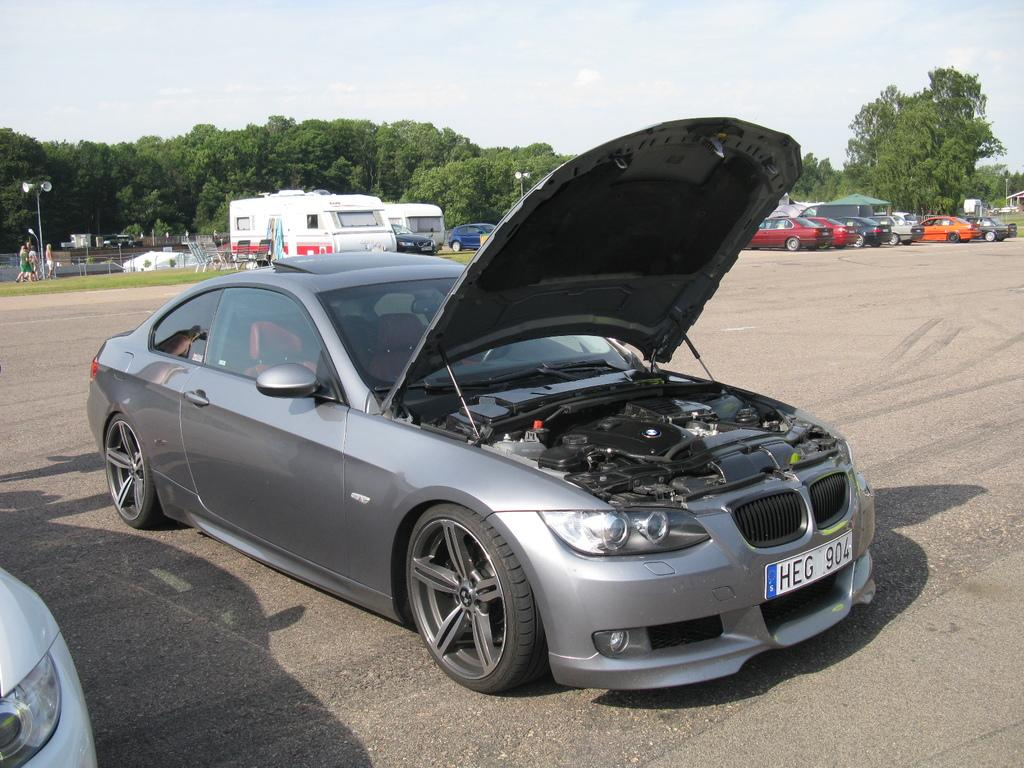What can be seen on the road in the image? There are many vehicles on the road in the image. What is located to the left of the image? There are poles to the left of the image. What is near the poles? There are people near the poles. What is visible in the background of the image? There are many trees and clouds in the background of the image, and the sky is also visible. How many babies are sitting on the branches of the trees in the image? There are no babies present in the image; it features vehicles on the road, poles, people, trees, clouds, and the sky. What type of bird can be seen flying near the clouds in the image? There are no birds visible in the image; it only features vehicles, poles, people, trees, clouds, and the sky. 